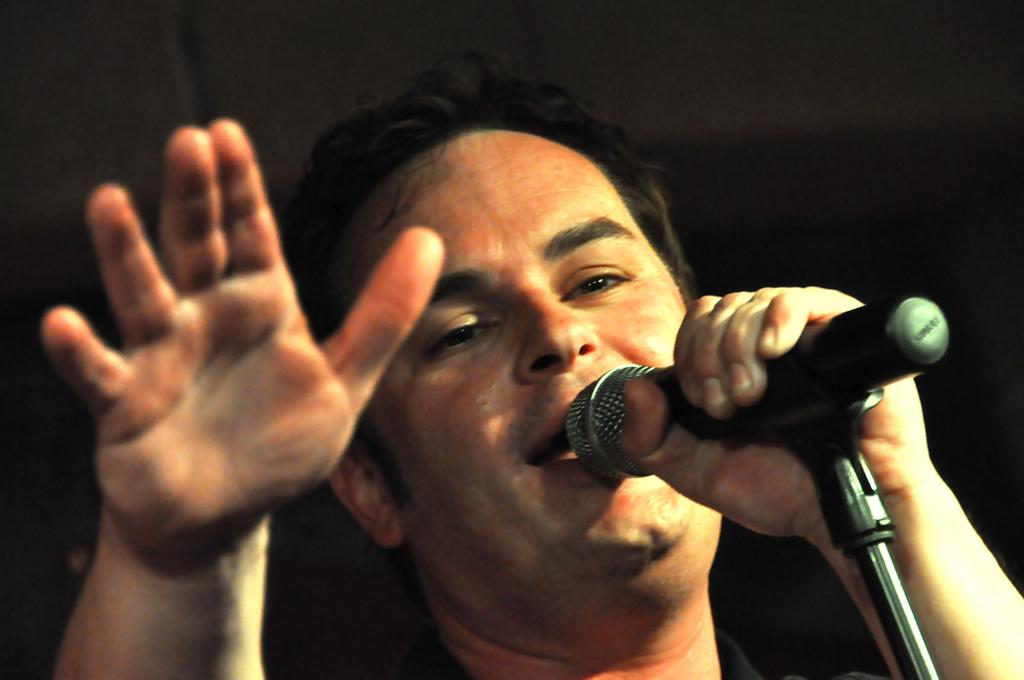Who is the main subject in the image? There is a man in the image. What is the man holding in the image? The man is holding a microphone. What is the man doing in the image? The man is singing. What color is the background of the image? The background of the image is black. What type of skin can be seen on the man's hands in the image? There is no information about the man's skin in the image, as it is not mentioned in the provided facts. 